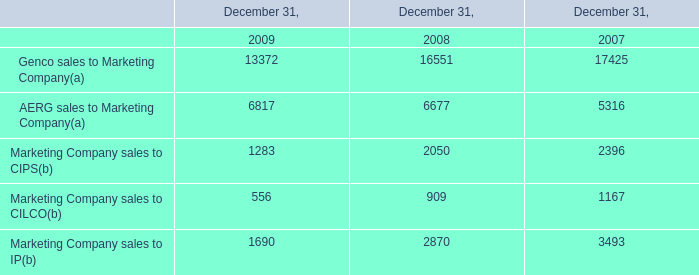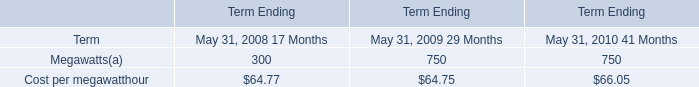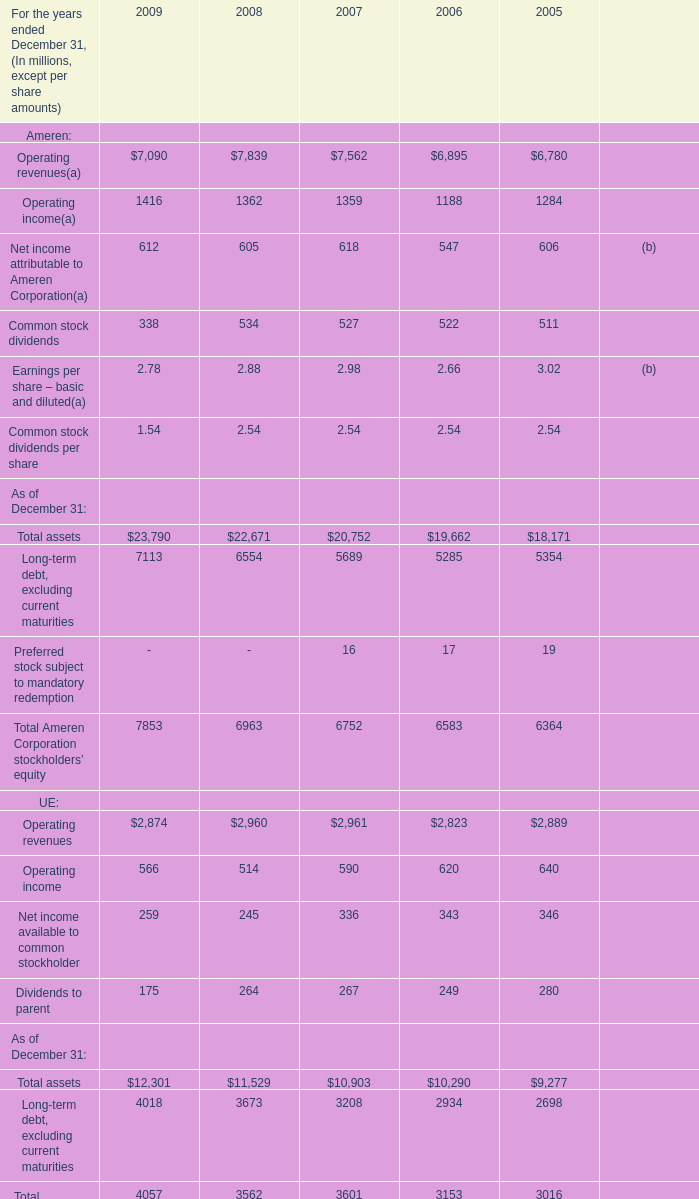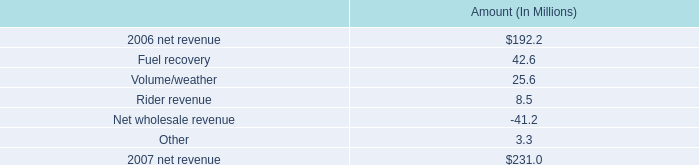What's the total amount of Ameren: Operating revenues, Ameren: Operating income, Ameren: Net income attributable to Ameren Corporation and Ameren: Common stock dividends in 2009? (in million) 
Computations: (((7090 + 1416) + 612) + 338)
Answer: 9456.0. 